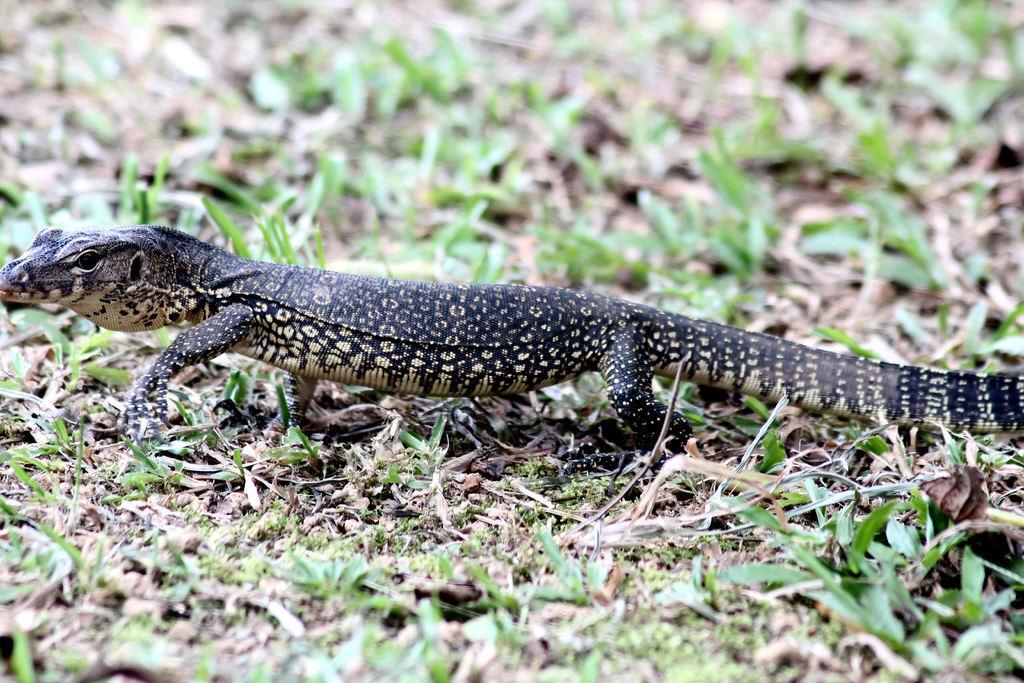How would you summarize this image in a sentence or two? In this image, we can see an alligator lizard on the grass. 